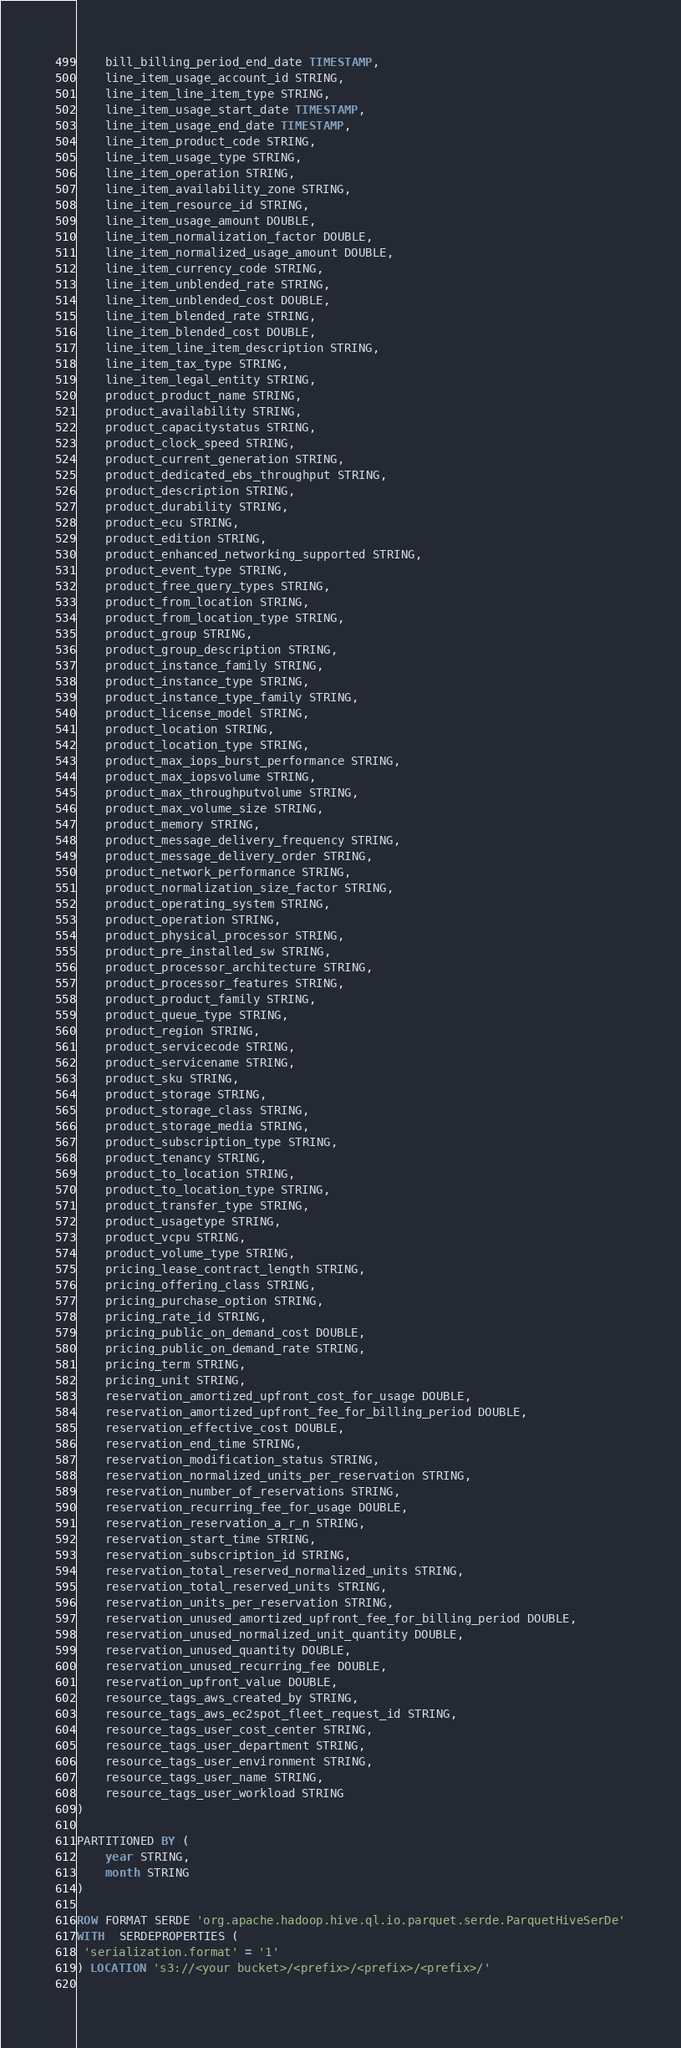Convert code to text. <code><loc_0><loc_0><loc_500><loc_500><_SQL_>	bill_billing_period_end_date TIMESTAMP,
	line_item_usage_account_id STRING,
	line_item_line_item_type STRING,
	line_item_usage_start_date TIMESTAMP,
	line_item_usage_end_date TIMESTAMP,
	line_item_product_code STRING,
	line_item_usage_type STRING,
	line_item_operation STRING,
	line_item_availability_zone STRING,
	line_item_resource_id STRING,
	line_item_usage_amount DOUBLE,
	line_item_normalization_factor DOUBLE,
	line_item_normalized_usage_amount DOUBLE,
	line_item_currency_code STRING,
	line_item_unblended_rate STRING,
	line_item_unblended_cost DOUBLE,
	line_item_blended_rate STRING,
	line_item_blended_cost DOUBLE,
	line_item_line_item_description STRING,
	line_item_tax_type STRING,
	line_item_legal_entity STRING,
	product_product_name STRING,
	product_availability STRING,
	product_capacitystatus STRING,
	product_clock_speed STRING,
	product_current_generation STRING,
	product_dedicated_ebs_throughput STRING,
	product_description STRING,
	product_durability STRING,
	product_ecu STRING,
	product_edition STRING,
	product_enhanced_networking_supported STRING,
	product_event_type STRING,
	product_free_query_types STRING,
	product_from_location STRING,
	product_from_location_type STRING,
	product_group STRING,
	product_group_description STRING,
	product_instance_family STRING,
	product_instance_type STRING,
	product_instance_type_family STRING,
	product_license_model STRING,
	product_location STRING,
	product_location_type STRING,
	product_max_iops_burst_performance STRING,
	product_max_iopsvolume STRING,
	product_max_throughputvolume STRING,
	product_max_volume_size STRING,
	product_memory STRING,
	product_message_delivery_frequency STRING,
	product_message_delivery_order STRING,
	product_network_performance STRING,
	product_normalization_size_factor STRING,
	product_operating_system STRING,
	product_operation STRING,
	product_physical_processor STRING,
	product_pre_installed_sw STRING,
	product_processor_architecture STRING,
	product_processor_features STRING,
	product_product_family STRING,
	product_queue_type STRING,
	product_region STRING,
	product_servicecode STRING,
	product_servicename STRING,
	product_sku STRING,
	product_storage STRING,
	product_storage_class STRING,
	product_storage_media STRING,
	product_subscription_type STRING,
	product_tenancy STRING,
	product_to_location STRING,
	product_to_location_type STRING,
	product_transfer_type STRING,
	product_usagetype STRING,
	product_vcpu STRING,
	product_volume_type STRING,
	pricing_lease_contract_length STRING,
	pricing_offering_class STRING,
	pricing_purchase_option STRING,
	pricing_rate_id STRING,
	pricing_public_on_demand_cost DOUBLE,
	pricing_public_on_demand_rate STRING,
	pricing_term STRING,
	pricing_unit STRING,
	reservation_amortized_upfront_cost_for_usage DOUBLE,
	reservation_amortized_upfront_fee_for_billing_period DOUBLE,
	reservation_effective_cost DOUBLE,
	reservation_end_time STRING,
	reservation_modification_status STRING,
	reservation_normalized_units_per_reservation STRING,
	reservation_number_of_reservations STRING,
	reservation_recurring_fee_for_usage DOUBLE,
	reservation_reservation_a_r_n STRING,
	reservation_start_time STRING,
	reservation_subscription_id STRING,
	reservation_total_reserved_normalized_units STRING,
	reservation_total_reserved_units STRING,
	reservation_units_per_reservation STRING,
	reservation_unused_amortized_upfront_fee_for_billing_period DOUBLE,
	reservation_unused_normalized_unit_quantity DOUBLE,
	reservation_unused_quantity DOUBLE,
	reservation_unused_recurring_fee DOUBLE,
	reservation_upfront_value DOUBLE,
	resource_tags_aws_created_by STRING,
	resource_tags_aws_ec2spot_fleet_request_id STRING,
	resource_tags_user_cost_center STRING,
	resource_tags_user_department STRING,
	resource_tags_user_environment STRING,
	resource_tags_user_name STRING,
	resource_tags_user_workload STRING
)

PARTITIONED BY (
	year STRING,
	month STRING
)
         
ROW FORMAT SERDE 'org.apache.hadoop.hive.ql.io.parquet.serde.ParquetHiveSerDe'
WITH  SERDEPROPERTIES (
 'serialization.format' = '1'
) LOCATION 's3://<your bucket>/<prefix>/<prefix>/<prefix>/'
     </code> 